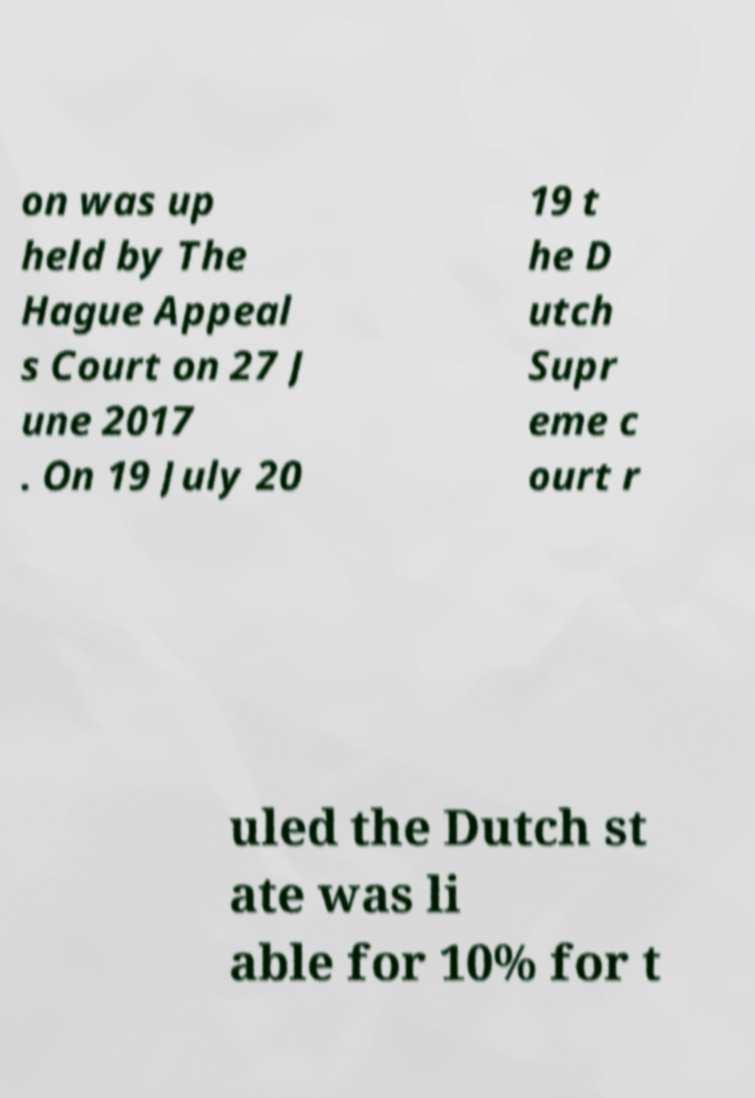What messages or text are displayed in this image? I need them in a readable, typed format. on was up held by The Hague Appeal s Court on 27 J une 2017 . On 19 July 20 19 t he D utch Supr eme c ourt r uled the Dutch st ate was li able for 10% for t 